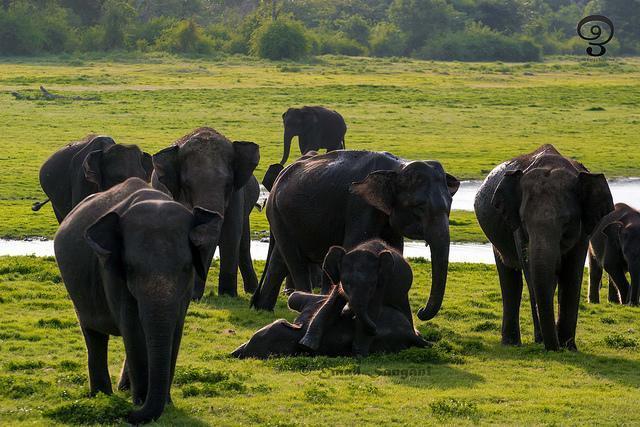How many elephants are visible?
Give a very brief answer. 9. 